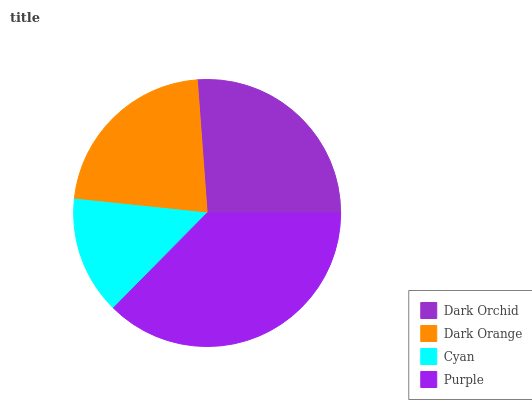Is Cyan the minimum?
Answer yes or no. Yes. Is Purple the maximum?
Answer yes or no. Yes. Is Dark Orange the minimum?
Answer yes or no. No. Is Dark Orange the maximum?
Answer yes or no. No. Is Dark Orchid greater than Dark Orange?
Answer yes or no. Yes. Is Dark Orange less than Dark Orchid?
Answer yes or no. Yes. Is Dark Orange greater than Dark Orchid?
Answer yes or no. No. Is Dark Orchid less than Dark Orange?
Answer yes or no. No. Is Dark Orchid the high median?
Answer yes or no. Yes. Is Dark Orange the low median?
Answer yes or no. Yes. Is Purple the high median?
Answer yes or no. No. Is Dark Orchid the low median?
Answer yes or no. No. 